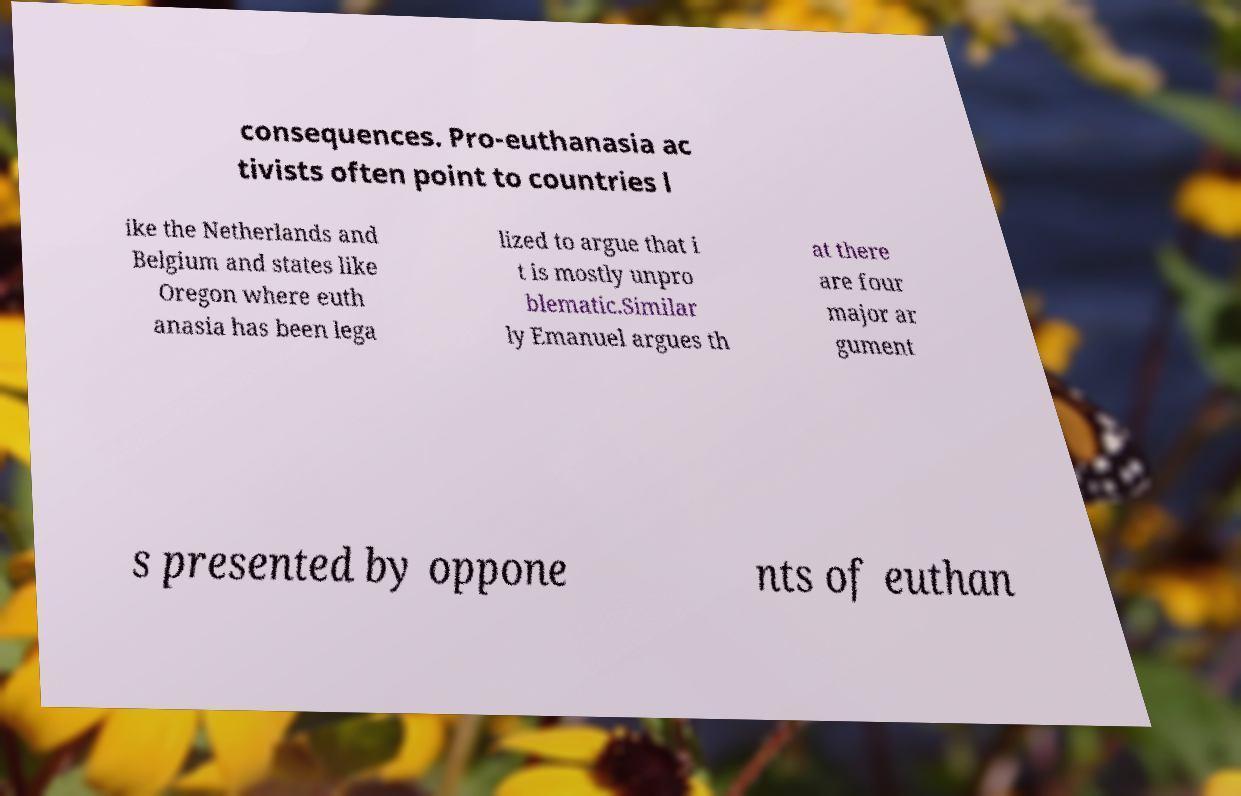For documentation purposes, I need the text within this image transcribed. Could you provide that? consequences. Pro-euthanasia ac tivists often point to countries l ike the Netherlands and Belgium and states like Oregon where euth anasia has been lega lized to argue that i t is mostly unpro blematic.Similar ly Emanuel argues th at there are four major ar gument s presented by oppone nts of euthan 